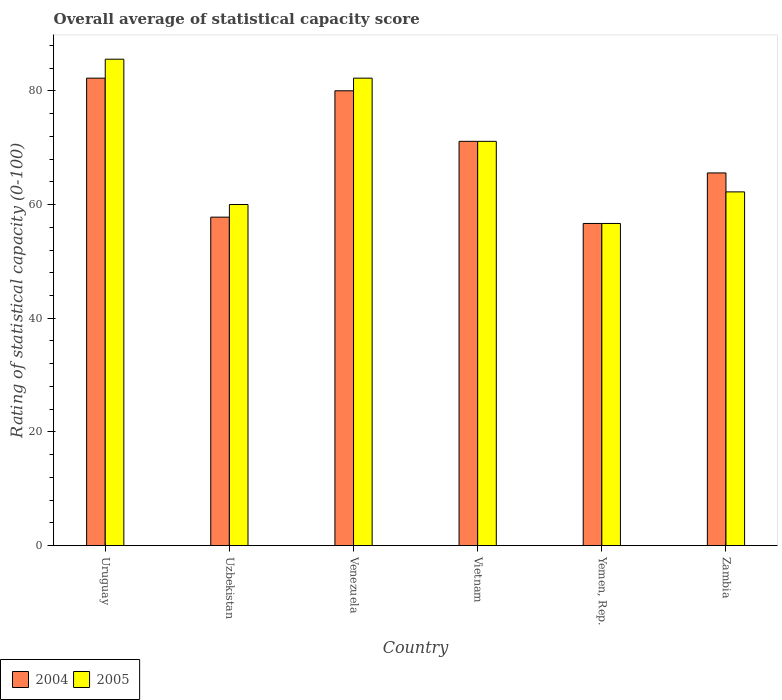How many different coloured bars are there?
Offer a terse response. 2. How many groups of bars are there?
Provide a short and direct response. 6. How many bars are there on the 4th tick from the left?
Your answer should be compact. 2. What is the label of the 5th group of bars from the left?
Your answer should be compact. Yemen, Rep. In how many cases, is the number of bars for a given country not equal to the number of legend labels?
Provide a succinct answer. 0. What is the rating of statistical capacity in 2005 in Venezuela?
Offer a very short reply. 82.22. Across all countries, what is the maximum rating of statistical capacity in 2004?
Your answer should be compact. 82.22. Across all countries, what is the minimum rating of statistical capacity in 2004?
Provide a short and direct response. 56.67. In which country was the rating of statistical capacity in 2004 maximum?
Provide a short and direct response. Uruguay. In which country was the rating of statistical capacity in 2005 minimum?
Your answer should be compact. Yemen, Rep. What is the total rating of statistical capacity in 2004 in the graph?
Ensure brevity in your answer.  413.33. What is the difference between the rating of statistical capacity in 2005 in Uzbekistan and that in Vietnam?
Offer a terse response. -11.11. What is the difference between the rating of statistical capacity in 2004 in Uzbekistan and the rating of statistical capacity in 2005 in Uruguay?
Give a very brief answer. -27.78. What is the average rating of statistical capacity in 2005 per country?
Your response must be concise. 69.63. What is the difference between the rating of statistical capacity of/in 2004 and rating of statistical capacity of/in 2005 in Uruguay?
Ensure brevity in your answer.  -3.33. What is the ratio of the rating of statistical capacity in 2005 in Uzbekistan to that in Yemen, Rep.?
Make the answer very short. 1.06. Is the rating of statistical capacity in 2004 in Uruguay less than that in Zambia?
Keep it short and to the point. No. What is the difference between the highest and the second highest rating of statistical capacity in 2004?
Your response must be concise. -2.22. What is the difference between the highest and the lowest rating of statistical capacity in 2004?
Give a very brief answer. 25.56. In how many countries, is the rating of statistical capacity in 2005 greater than the average rating of statistical capacity in 2005 taken over all countries?
Your response must be concise. 3. How many bars are there?
Offer a terse response. 12. How many countries are there in the graph?
Give a very brief answer. 6. Are the values on the major ticks of Y-axis written in scientific E-notation?
Make the answer very short. No. Does the graph contain grids?
Your answer should be compact. No. How are the legend labels stacked?
Provide a short and direct response. Horizontal. What is the title of the graph?
Make the answer very short. Overall average of statistical capacity score. What is the label or title of the X-axis?
Keep it short and to the point. Country. What is the label or title of the Y-axis?
Ensure brevity in your answer.  Rating of statistical capacity (0-100). What is the Rating of statistical capacity (0-100) of 2004 in Uruguay?
Offer a terse response. 82.22. What is the Rating of statistical capacity (0-100) in 2005 in Uruguay?
Provide a succinct answer. 85.56. What is the Rating of statistical capacity (0-100) of 2004 in Uzbekistan?
Ensure brevity in your answer.  57.78. What is the Rating of statistical capacity (0-100) in 2004 in Venezuela?
Make the answer very short. 80. What is the Rating of statistical capacity (0-100) of 2005 in Venezuela?
Give a very brief answer. 82.22. What is the Rating of statistical capacity (0-100) of 2004 in Vietnam?
Your response must be concise. 71.11. What is the Rating of statistical capacity (0-100) of 2005 in Vietnam?
Give a very brief answer. 71.11. What is the Rating of statistical capacity (0-100) of 2004 in Yemen, Rep.?
Provide a succinct answer. 56.67. What is the Rating of statistical capacity (0-100) of 2005 in Yemen, Rep.?
Ensure brevity in your answer.  56.67. What is the Rating of statistical capacity (0-100) of 2004 in Zambia?
Make the answer very short. 65.56. What is the Rating of statistical capacity (0-100) in 2005 in Zambia?
Offer a terse response. 62.22. Across all countries, what is the maximum Rating of statistical capacity (0-100) of 2004?
Your answer should be very brief. 82.22. Across all countries, what is the maximum Rating of statistical capacity (0-100) of 2005?
Your response must be concise. 85.56. Across all countries, what is the minimum Rating of statistical capacity (0-100) in 2004?
Make the answer very short. 56.67. Across all countries, what is the minimum Rating of statistical capacity (0-100) of 2005?
Offer a terse response. 56.67. What is the total Rating of statistical capacity (0-100) in 2004 in the graph?
Your answer should be compact. 413.33. What is the total Rating of statistical capacity (0-100) of 2005 in the graph?
Ensure brevity in your answer.  417.78. What is the difference between the Rating of statistical capacity (0-100) of 2004 in Uruguay and that in Uzbekistan?
Give a very brief answer. 24.44. What is the difference between the Rating of statistical capacity (0-100) of 2005 in Uruguay and that in Uzbekistan?
Ensure brevity in your answer.  25.56. What is the difference between the Rating of statistical capacity (0-100) in 2004 in Uruguay and that in Venezuela?
Your response must be concise. 2.22. What is the difference between the Rating of statistical capacity (0-100) in 2005 in Uruguay and that in Venezuela?
Give a very brief answer. 3.33. What is the difference between the Rating of statistical capacity (0-100) of 2004 in Uruguay and that in Vietnam?
Your response must be concise. 11.11. What is the difference between the Rating of statistical capacity (0-100) in 2005 in Uruguay and that in Vietnam?
Give a very brief answer. 14.44. What is the difference between the Rating of statistical capacity (0-100) of 2004 in Uruguay and that in Yemen, Rep.?
Make the answer very short. 25.56. What is the difference between the Rating of statistical capacity (0-100) in 2005 in Uruguay and that in Yemen, Rep.?
Give a very brief answer. 28.89. What is the difference between the Rating of statistical capacity (0-100) in 2004 in Uruguay and that in Zambia?
Make the answer very short. 16.67. What is the difference between the Rating of statistical capacity (0-100) of 2005 in Uruguay and that in Zambia?
Your response must be concise. 23.33. What is the difference between the Rating of statistical capacity (0-100) of 2004 in Uzbekistan and that in Venezuela?
Offer a very short reply. -22.22. What is the difference between the Rating of statistical capacity (0-100) of 2005 in Uzbekistan and that in Venezuela?
Offer a very short reply. -22.22. What is the difference between the Rating of statistical capacity (0-100) in 2004 in Uzbekistan and that in Vietnam?
Your answer should be compact. -13.33. What is the difference between the Rating of statistical capacity (0-100) of 2005 in Uzbekistan and that in Vietnam?
Your response must be concise. -11.11. What is the difference between the Rating of statistical capacity (0-100) of 2004 in Uzbekistan and that in Yemen, Rep.?
Your response must be concise. 1.11. What is the difference between the Rating of statistical capacity (0-100) of 2004 in Uzbekistan and that in Zambia?
Your answer should be compact. -7.78. What is the difference between the Rating of statistical capacity (0-100) in 2005 in Uzbekistan and that in Zambia?
Offer a very short reply. -2.22. What is the difference between the Rating of statistical capacity (0-100) in 2004 in Venezuela and that in Vietnam?
Your response must be concise. 8.89. What is the difference between the Rating of statistical capacity (0-100) of 2005 in Venezuela and that in Vietnam?
Give a very brief answer. 11.11. What is the difference between the Rating of statistical capacity (0-100) in 2004 in Venezuela and that in Yemen, Rep.?
Ensure brevity in your answer.  23.33. What is the difference between the Rating of statistical capacity (0-100) of 2005 in Venezuela and that in Yemen, Rep.?
Offer a terse response. 25.56. What is the difference between the Rating of statistical capacity (0-100) of 2004 in Venezuela and that in Zambia?
Your answer should be very brief. 14.44. What is the difference between the Rating of statistical capacity (0-100) in 2004 in Vietnam and that in Yemen, Rep.?
Ensure brevity in your answer.  14.44. What is the difference between the Rating of statistical capacity (0-100) of 2005 in Vietnam and that in Yemen, Rep.?
Ensure brevity in your answer.  14.44. What is the difference between the Rating of statistical capacity (0-100) of 2004 in Vietnam and that in Zambia?
Your answer should be compact. 5.56. What is the difference between the Rating of statistical capacity (0-100) in 2005 in Vietnam and that in Zambia?
Provide a short and direct response. 8.89. What is the difference between the Rating of statistical capacity (0-100) of 2004 in Yemen, Rep. and that in Zambia?
Keep it short and to the point. -8.89. What is the difference between the Rating of statistical capacity (0-100) of 2005 in Yemen, Rep. and that in Zambia?
Your answer should be very brief. -5.56. What is the difference between the Rating of statistical capacity (0-100) in 2004 in Uruguay and the Rating of statistical capacity (0-100) in 2005 in Uzbekistan?
Provide a short and direct response. 22.22. What is the difference between the Rating of statistical capacity (0-100) of 2004 in Uruguay and the Rating of statistical capacity (0-100) of 2005 in Vietnam?
Provide a succinct answer. 11.11. What is the difference between the Rating of statistical capacity (0-100) of 2004 in Uruguay and the Rating of statistical capacity (0-100) of 2005 in Yemen, Rep.?
Your answer should be compact. 25.56. What is the difference between the Rating of statistical capacity (0-100) of 2004 in Uruguay and the Rating of statistical capacity (0-100) of 2005 in Zambia?
Your answer should be very brief. 20. What is the difference between the Rating of statistical capacity (0-100) in 2004 in Uzbekistan and the Rating of statistical capacity (0-100) in 2005 in Venezuela?
Your answer should be very brief. -24.44. What is the difference between the Rating of statistical capacity (0-100) of 2004 in Uzbekistan and the Rating of statistical capacity (0-100) of 2005 in Vietnam?
Provide a short and direct response. -13.33. What is the difference between the Rating of statistical capacity (0-100) of 2004 in Uzbekistan and the Rating of statistical capacity (0-100) of 2005 in Zambia?
Provide a short and direct response. -4.44. What is the difference between the Rating of statistical capacity (0-100) in 2004 in Venezuela and the Rating of statistical capacity (0-100) in 2005 in Vietnam?
Your response must be concise. 8.89. What is the difference between the Rating of statistical capacity (0-100) of 2004 in Venezuela and the Rating of statistical capacity (0-100) of 2005 in Yemen, Rep.?
Offer a terse response. 23.33. What is the difference between the Rating of statistical capacity (0-100) of 2004 in Venezuela and the Rating of statistical capacity (0-100) of 2005 in Zambia?
Make the answer very short. 17.78. What is the difference between the Rating of statistical capacity (0-100) in 2004 in Vietnam and the Rating of statistical capacity (0-100) in 2005 in Yemen, Rep.?
Ensure brevity in your answer.  14.44. What is the difference between the Rating of statistical capacity (0-100) in 2004 in Vietnam and the Rating of statistical capacity (0-100) in 2005 in Zambia?
Offer a terse response. 8.89. What is the difference between the Rating of statistical capacity (0-100) in 2004 in Yemen, Rep. and the Rating of statistical capacity (0-100) in 2005 in Zambia?
Provide a short and direct response. -5.56. What is the average Rating of statistical capacity (0-100) in 2004 per country?
Your answer should be very brief. 68.89. What is the average Rating of statistical capacity (0-100) in 2005 per country?
Your response must be concise. 69.63. What is the difference between the Rating of statistical capacity (0-100) in 2004 and Rating of statistical capacity (0-100) in 2005 in Uzbekistan?
Ensure brevity in your answer.  -2.22. What is the difference between the Rating of statistical capacity (0-100) of 2004 and Rating of statistical capacity (0-100) of 2005 in Venezuela?
Provide a succinct answer. -2.22. What is the difference between the Rating of statistical capacity (0-100) in 2004 and Rating of statistical capacity (0-100) in 2005 in Yemen, Rep.?
Make the answer very short. 0. What is the ratio of the Rating of statistical capacity (0-100) of 2004 in Uruguay to that in Uzbekistan?
Your response must be concise. 1.42. What is the ratio of the Rating of statistical capacity (0-100) in 2005 in Uruguay to that in Uzbekistan?
Your answer should be very brief. 1.43. What is the ratio of the Rating of statistical capacity (0-100) of 2004 in Uruguay to that in Venezuela?
Provide a short and direct response. 1.03. What is the ratio of the Rating of statistical capacity (0-100) in 2005 in Uruguay to that in Venezuela?
Provide a short and direct response. 1.04. What is the ratio of the Rating of statistical capacity (0-100) of 2004 in Uruguay to that in Vietnam?
Give a very brief answer. 1.16. What is the ratio of the Rating of statistical capacity (0-100) in 2005 in Uruguay to that in Vietnam?
Offer a terse response. 1.2. What is the ratio of the Rating of statistical capacity (0-100) of 2004 in Uruguay to that in Yemen, Rep.?
Offer a terse response. 1.45. What is the ratio of the Rating of statistical capacity (0-100) of 2005 in Uruguay to that in Yemen, Rep.?
Give a very brief answer. 1.51. What is the ratio of the Rating of statistical capacity (0-100) in 2004 in Uruguay to that in Zambia?
Ensure brevity in your answer.  1.25. What is the ratio of the Rating of statistical capacity (0-100) of 2005 in Uruguay to that in Zambia?
Your response must be concise. 1.38. What is the ratio of the Rating of statistical capacity (0-100) of 2004 in Uzbekistan to that in Venezuela?
Ensure brevity in your answer.  0.72. What is the ratio of the Rating of statistical capacity (0-100) in 2005 in Uzbekistan to that in Venezuela?
Keep it short and to the point. 0.73. What is the ratio of the Rating of statistical capacity (0-100) of 2004 in Uzbekistan to that in Vietnam?
Provide a short and direct response. 0.81. What is the ratio of the Rating of statistical capacity (0-100) in 2005 in Uzbekistan to that in Vietnam?
Keep it short and to the point. 0.84. What is the ratio of the Rating of statistical capacity (0-100) of 2004 in Uzbekistan to that in Yemen, Rep.?
Your response must be concise. 1.02. What is the ratio of the Rating of statistical capacity (0-100) in 2005 in Uzbekistan to that in Yemen, Rep.?
Make the answer very short. 1.06. What is the ratio of the Rating of statistical capacity (0-100) in 2004 in Uzbekistan to that in Zambia?
Offer a very short reply. 0.88. What is the ratio of the Rating of statistical capacity (0-100) in 2005 in Venezuela to that in Vietnam?
Your response must be concise. 1.16. What is the ratio of the Rating of statistical capacity (0-100) of 2004 in Venezuela to that in Yemen, Rep.?
Your answer should be very brief. 1.41. What is the ratio of the Rating of statistical capacity (0-100) in 2005 in Venezuela to that in Yemen, Rep.?
Your response must be concise. 1.45. What is the ratio of the Rating of statistical capacity (0-100) in 2004 in Venezuela to that in Zambia?
Offer a terse response. 1.22. What is the ratio of the Rating of statistical capacity (0-100) of 2005 in Venezuela to that in Zambia?
Offer a very short reply. 1.32. What is the ratio of the Rating of statistical capacity (0-100) in 2004 in Vietnam to that in Yemen, Rep.?
Ensure brevity in your answer.  1.25. What is the ratio of the Rating of statistical capacity (0-100) in 2005 in Vietnam to that in Yemen, Rep.?
Your answer should be very brief. 1.25. What is the ratio of the Rating of statistical capacity (0-100) in 2004 in Vietnam to that in Zambia?
Keep it short and to the point. 1.08. What is the ratio of the Rating of statistical capacity (0-100) in 2004 in Yemen, Rep. to that in Zambia?
Your response must be concise. 0.86. What is the ratio of the Rating of statistical capacity (0-100) of 2005 in Yemen, Rep. to that in Zambia?
Your answer should be compact. 0.91. What is the difference between the highest and the second highest Rating of statistical capacity (0-100) of 2004?
Provide a succinct answer. 2.22. What is the difference between the highest and the second highest Rating of statistical capacity (0-100) of 2005?
Provide a succinct answer. 3.33. What is the difference between the highest and the lowest Rating of statistical capacity (0-100) of 2004?
Ensure brevity in your answer.  25.56. What is the difference between the highest and the lowest Rating of statistical capacity (0-100) of 2005?
Offer a terse response. 28.89. 